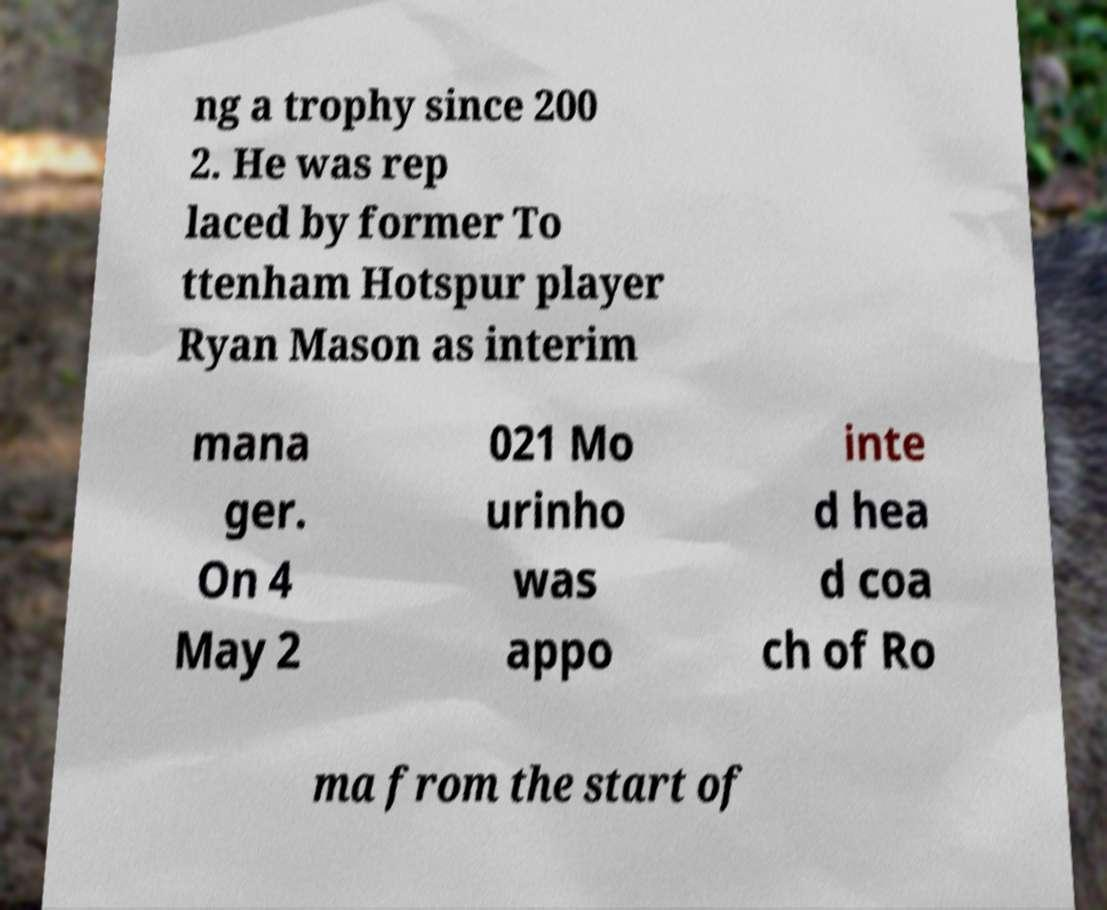Could you extract and type out the text from this image? ng a trophy since 200 2. He was rep laced by former To ttenham Hotspur player Ryan Mason as interim mana ger. On 4 May 2 021 Mo urinho was appo inte d hea d coa ch of Ro ma from the start of 